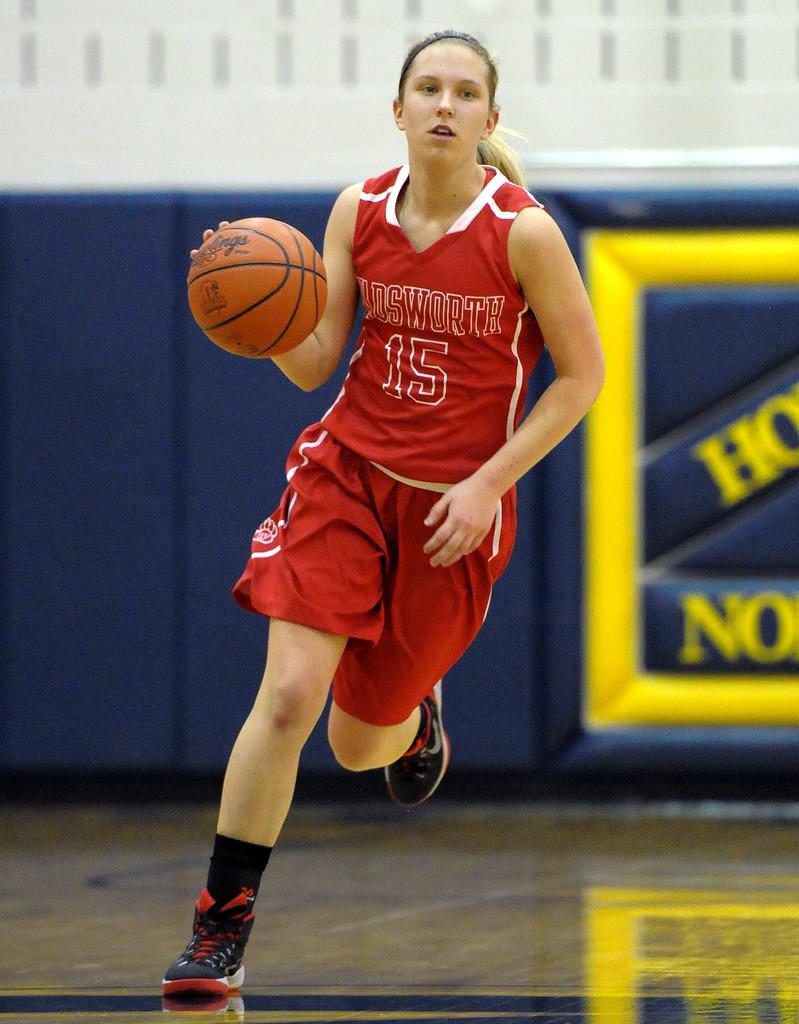<image>
Provide a brief description of the given image. Player number 15 is dribbling the basketball and running. 